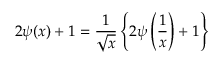<formula> <loc_0><loc_0><loc_500><loc_500>2 \psi ( x ) + 1 = { \frac { 1 } { \sqrt { x } } } \left \{ 2 \psi \left ( { \frac { 1 } { x } } \right ) + 1 \right \}</formula> 